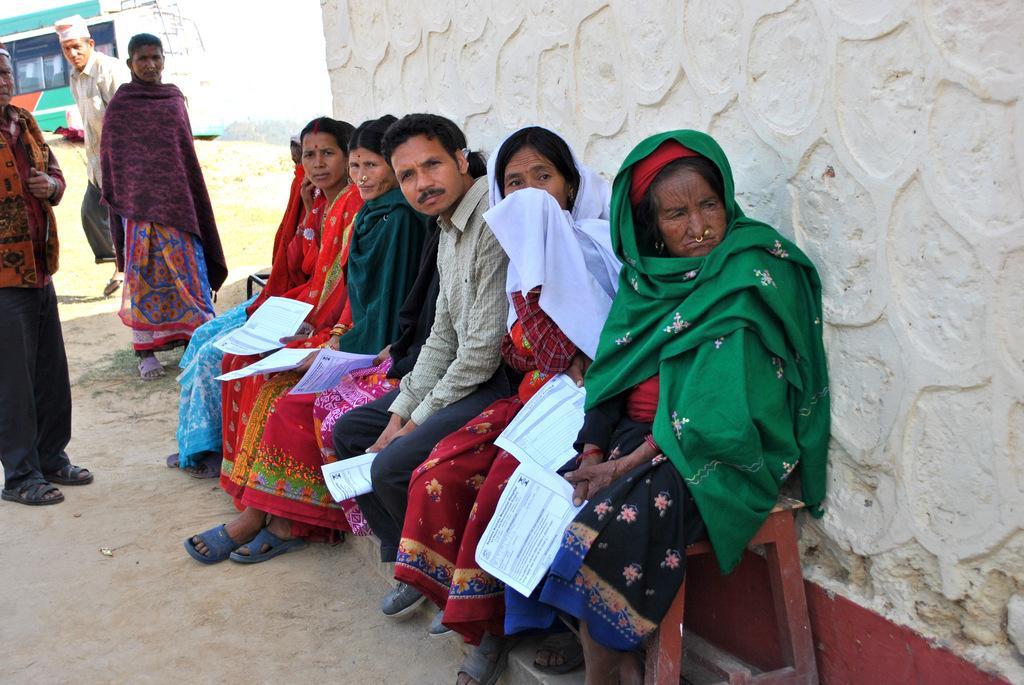Can you describe this image briefly? Few people are sitting on bench and these people are standing and these people are holding papers,behind these people we can see wall. In the background we can see bus and sky. 